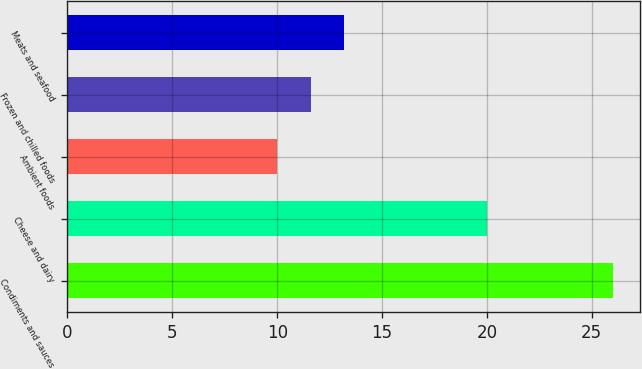Convert chart. <chart><loc_0><loc_0><loc_500><loc_500><bar_chart><fcel>Condiments and sauces<fcel>Cheese and dairy<fcel>Ambient foods<fcel>Frozen and chilled foods<fcel>Meats and seafood<nl><fcel>26<fcel>20<fcel>10<fcel>11.6<fcel>13.2<nl></chart> 